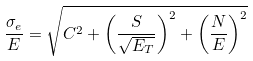Convert formula to latex. <formula><loc_0><loc_0><loc_500><loc_500>\frac { \sigma _ { e } } { E } = \sqrt { C ^ { 2 } + \left ( \frac { S } { \sqrt { E _ { T } } } \right ) ^ { 2 } + \left ( \frac { N } { E } \right ) ^ { 2 } }</formula> 